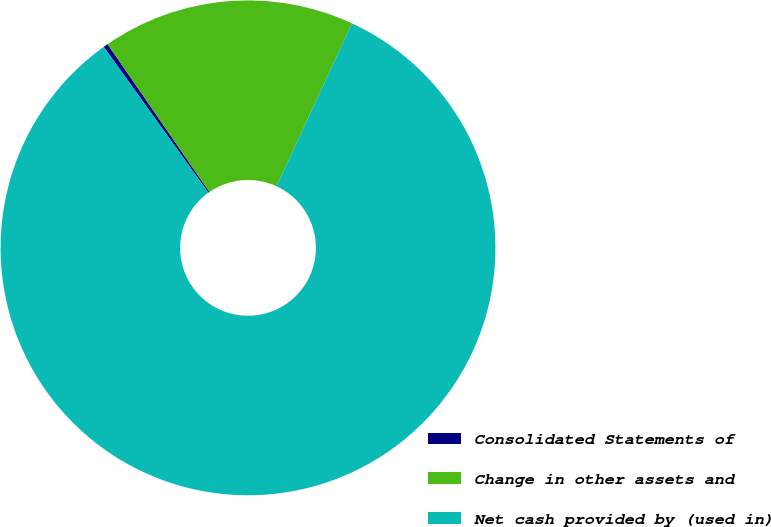Convert chart. <chart><loc_0><loc_0><loc_500><loc_500><pie_chart><fcel>Consolidated Statements of<fcel>Change in other assets and<fcel>Net cash provided by (used in)<nl><fcel>0.3%<fcel>16.51%<fcel>83.19%<nl></chart> 